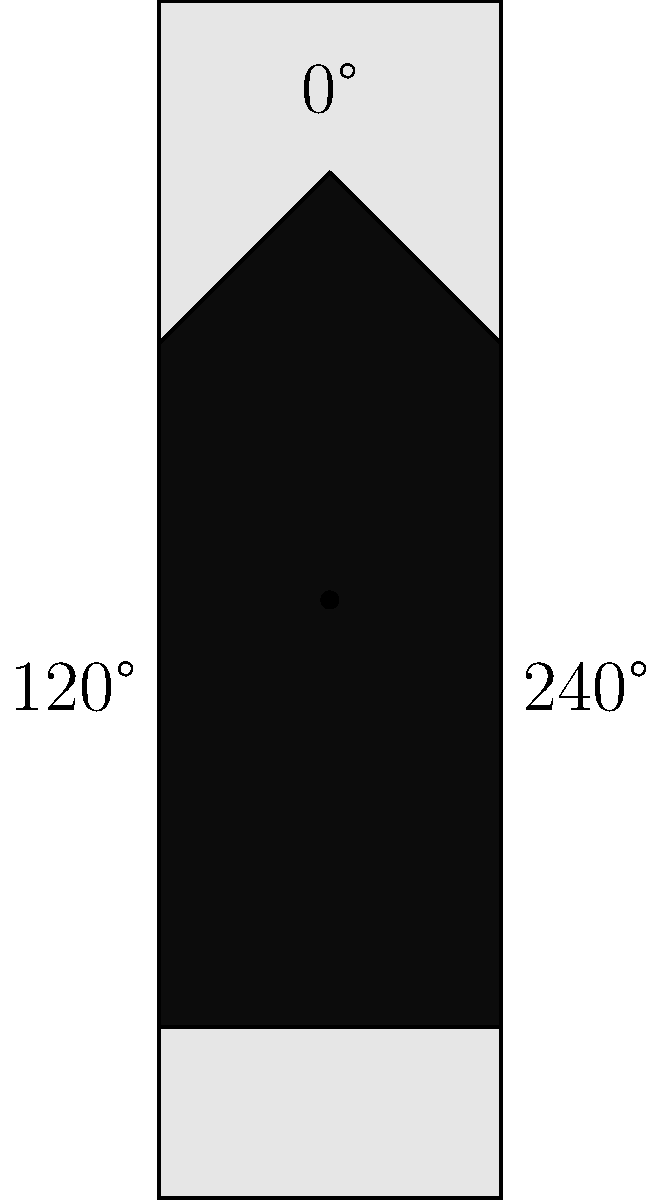A vintage fountain pen has a unique clip mechanism that rotates in discrete steps. The clip can be positioned at 0°, 120°, or 240° around the cap. If the clip is currently at 0° and you perform the rotation sequence: rotate clockwise by 120°, then counterclockwise by 240°, and finally clockwise by 120°, what will be the final position of the clip? Express your answer in degrees. Let's approach this step-by-step using group theory concepts:

1) First, we need to understand that this is a cyclic group of order 3, often denoted as $C_3$ or $\mathbb{Z}_3$.

2) We can represent the rotations as follows:
   - Clockwise 120° rotation: $r$
   - Counterclockwise 240° rotation: $r^{-2}$ (equivalent to a clockwise 120° rotation)

3) The sequence of rotations can be written as: $r \cdot r^{-2} \cdot r$

4) Now, let's simplify:
   $r \cdot r^{-2} \cdot r = r^{1-2+1} = r^0$

5) In group theory, $r^0$ represents the identity element, which means no net rotation.

6) Therefore, after this sequence of rotations, the clip will return to its original position of 0°.
Answer: 0° 